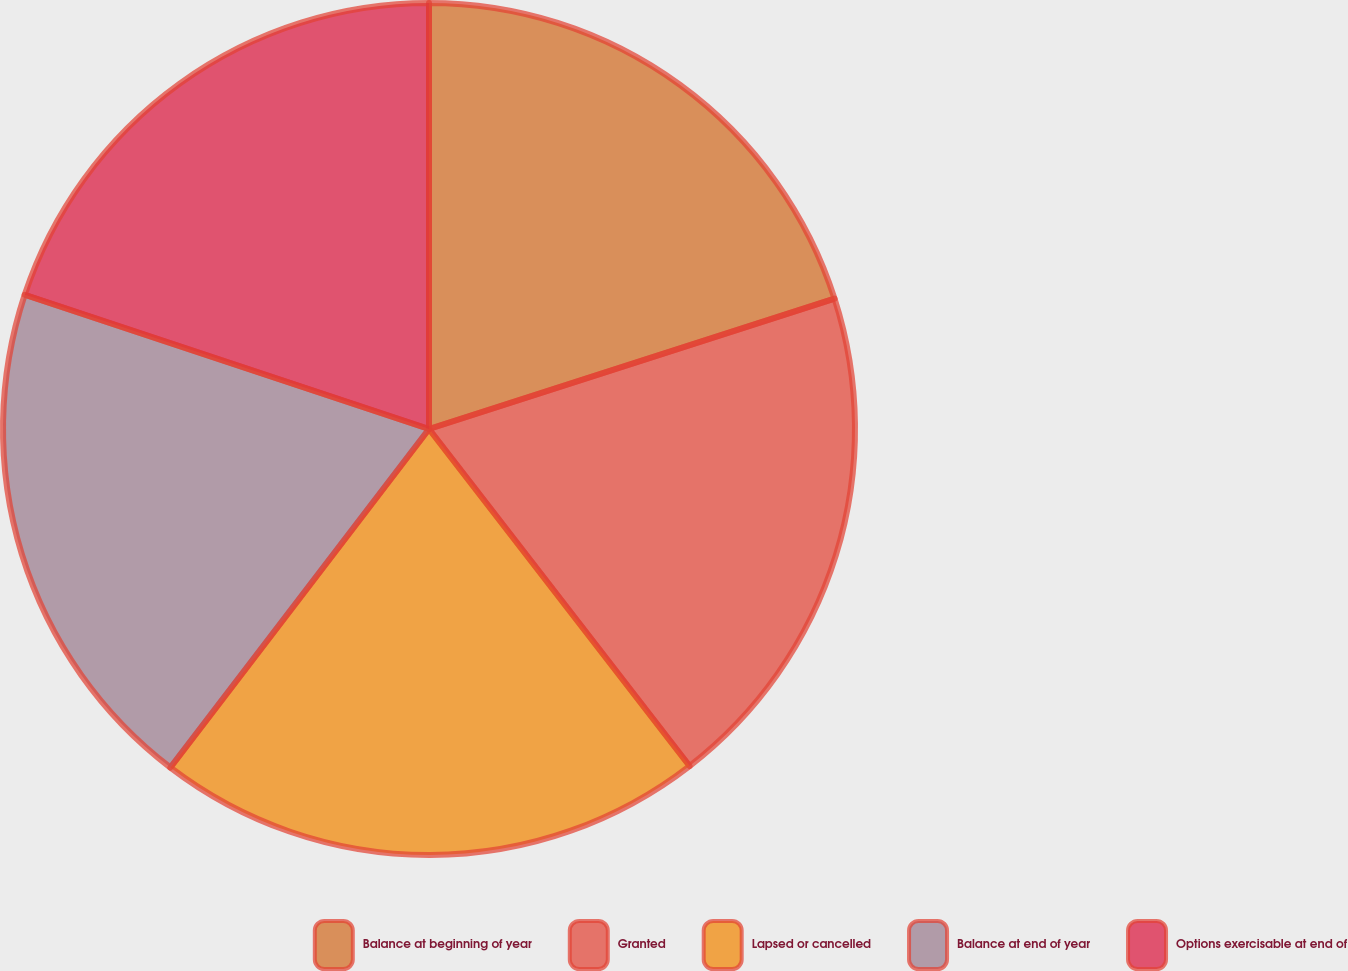Convert chart. <chart><loc_0><loc_0><loc_500><loc_500><pie_chart><fcel>Balance at beginning of year<fcel>Granted<fcel>Lapsed or cancelled<fcel>Balance at end of year<fcel>Options exercisable at end of<nl><fcel>20.05%<fcel>19.48%<fcel>20.86%<fcel>19.72%<fcel>19.9%<nl></chart> 